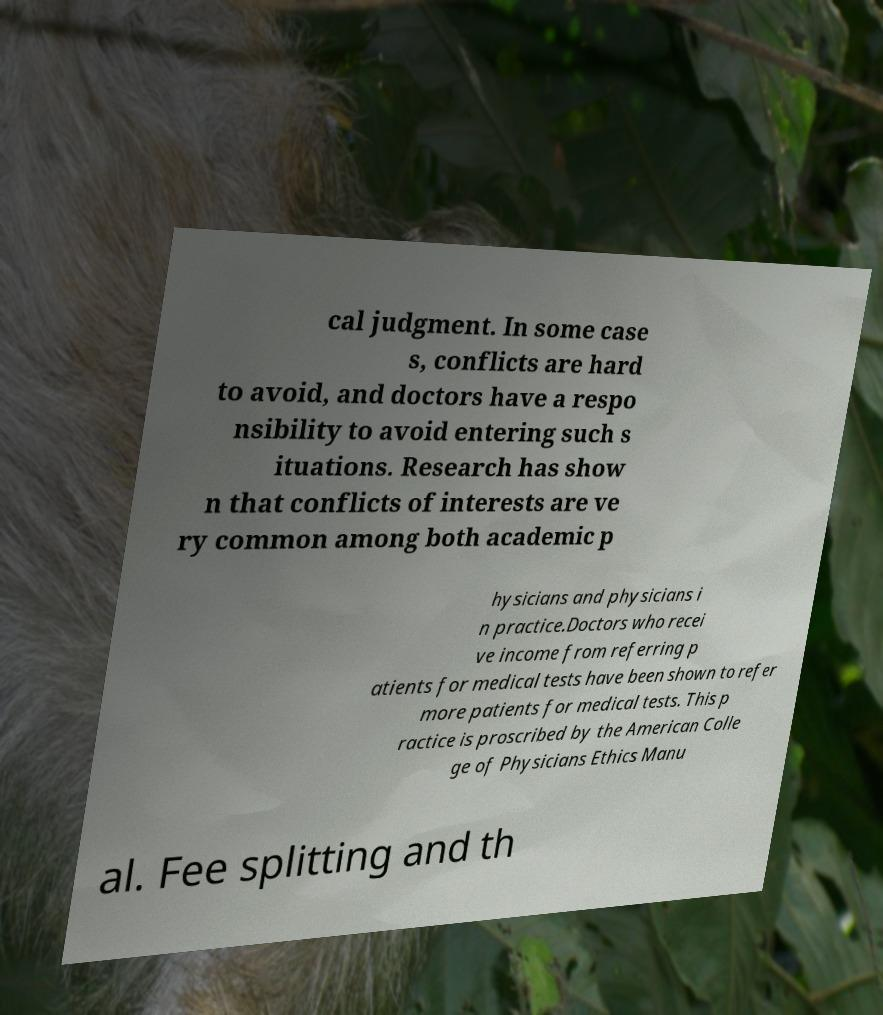Could you assist in decoding the text presented in this image and type it out clearly? cal judgment. In some case s, conflicts are hard to avoid, and doctors have a respo nsibility to avoid entering such s ituations. Research has show n that conflicts of interests are ve ry common among both academic p hysicians and physicians i n practice.Doctors who recei ve income from referring p atients for medical tests have been shown to refer more patients for medical tests. This p ractice is proscribed by the American Colle ge of Physicians Ethics Manu al. Fee splitting and th 